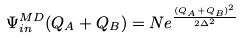Convert formula to latex. <formula><loc_0><loc_0><loc_500><loc_500>\Psi _ { i n } ^ { M D } ( Q _ { A } + Q _ { B } ) = N e ^ { \frac { { ( Q _ { A } + Q _ { B } ) ^ { 2 } } } { 2 \Delta ^ { 2 } } }</formula> 